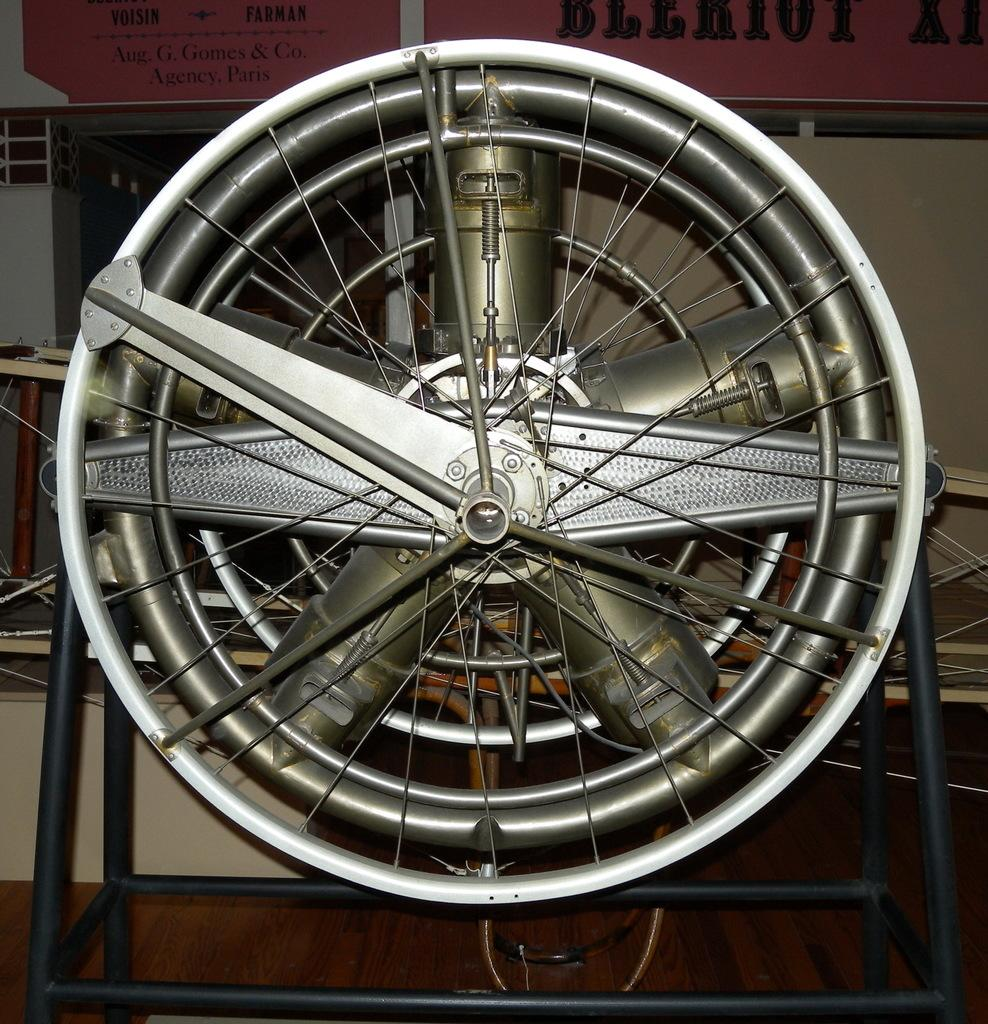What is the main object in the image? There is an electric fan in the image. Where is the electric fan placed? The electric fan is placed on a wooden desk. What can be seen in the background of the image? There is a desk, mechanical objects, and a wall in the background of the image. How many pizzas are being served to the passenger in the image? There are no pizzas or passengers present in the image. How many legs does the electric fan have in the image? The electric fan in the image has two legs, which are used for support and stability. 